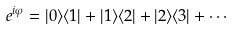<formula> <loc_0><loc_0><loc_500><loc_500>e ^ { i \varphi } = | 0 \rangle \langle 1 | + | 1 \rangle \langle 2 | + | 2 \rangle \langle 3 | + \cdots</formula> 